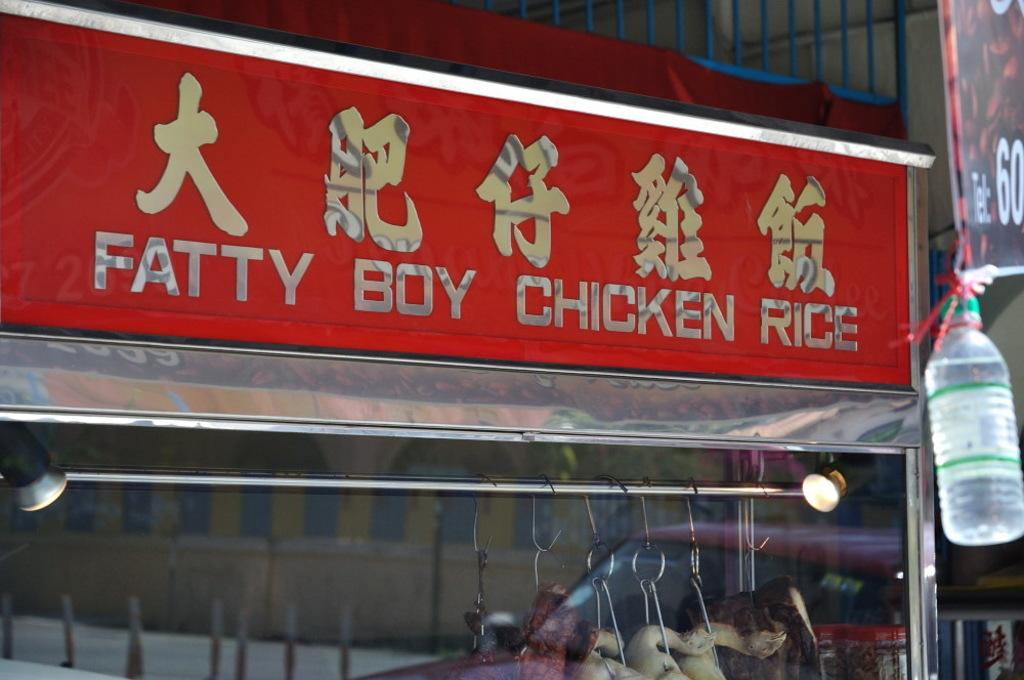<image>
Render a clear and concise summary of the photo. A red sign on the outside of a restaurant that says Fatty Boy Chicken Rice. 